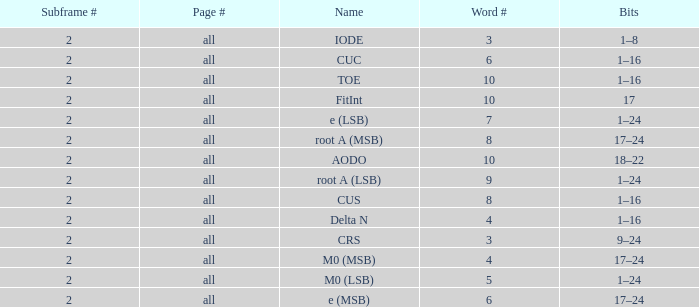What is the total subframe count with Bits of 18–22? 2.0. 